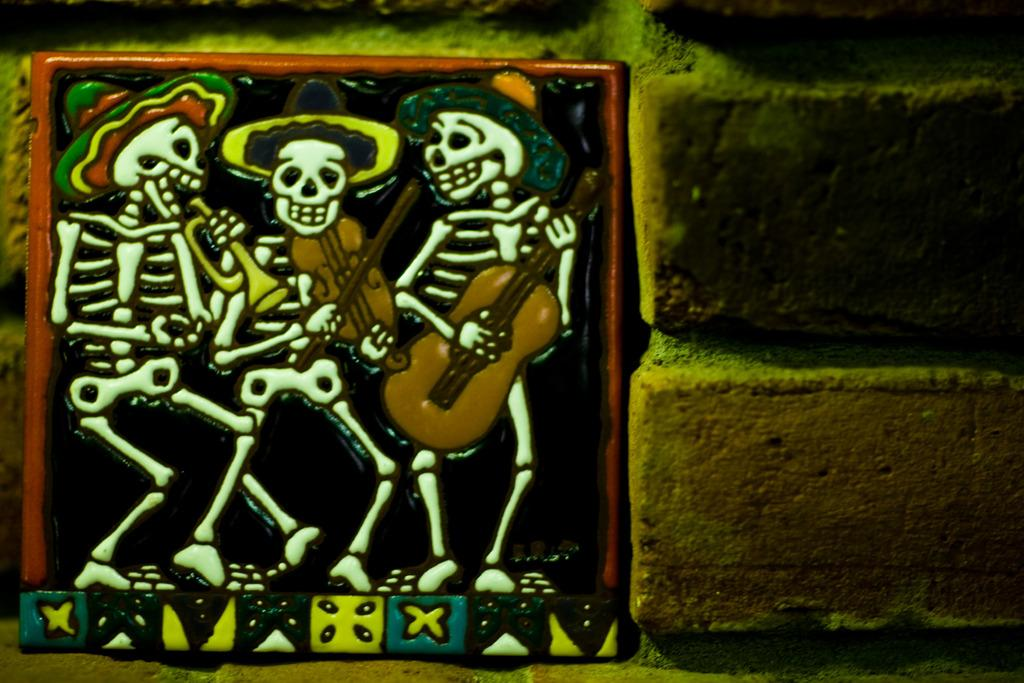What is attached to the wall in the image? There is a tile attached to the wall in the image. What is depicted on the tile? The tile has an image of three skeletons. What are the skeletons doing in the image? The skeletons are playing guitars in the image. What type of pickle is being used as a sound amplifier for the guitars in the image? There is no pickle present in the image, and the guitars are not being amplified by any object. 